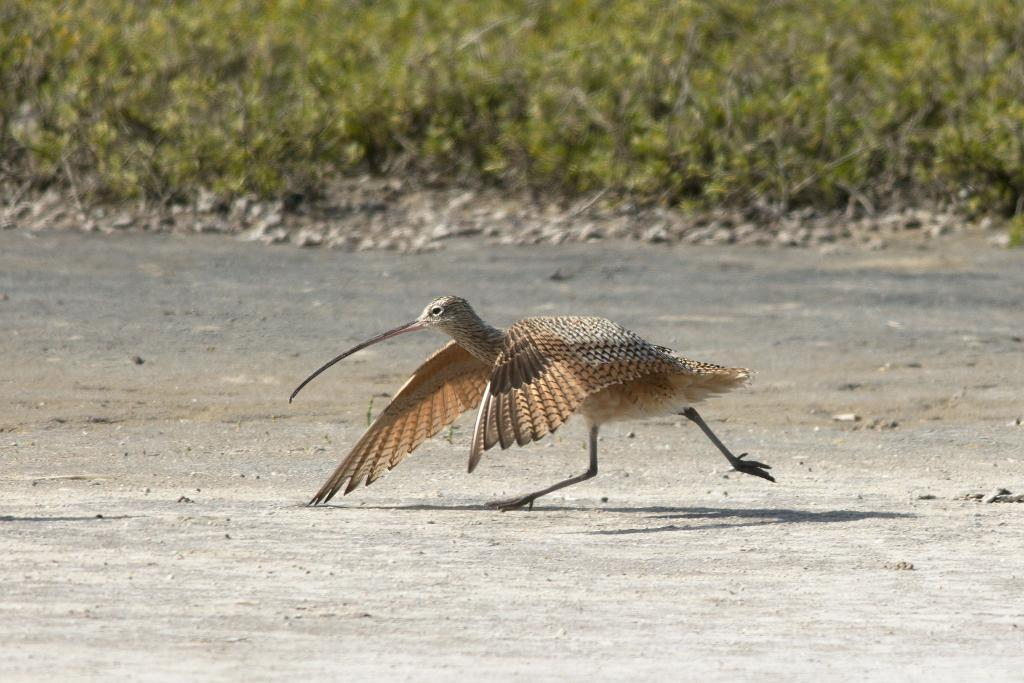What is the main subject in the center of the image? There is a dowitcher in the center of the image. What can be seen at the top side of the image? There is greenery at the top side of the image. What type of cake is being served at the amusement park in the image? There is no cake or amusement park present in the image; it features a dowitcher and greenery. What educational institution is depicted in the image? There is no educational institution present in the image; it features a dowitcher and greenery. 